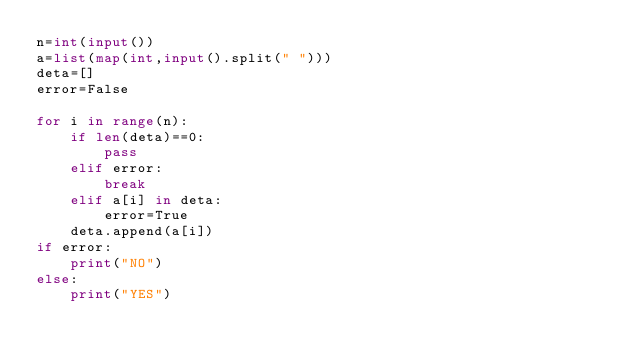Convert code to text. <code><loc_0><loc_0><loc_500><loc_500><_Python_>n=int(input())
a=list(map(int,input().split(" ")))
deta=[]
error=False
    
for i in range(n):
    if len(deta)==0:
        pass
    elif error:
        break
    elif a[i] in deta:
        error=True
    deta.append(a[i])
if error:
    print("NO")
else:
    print("YES")</code> 